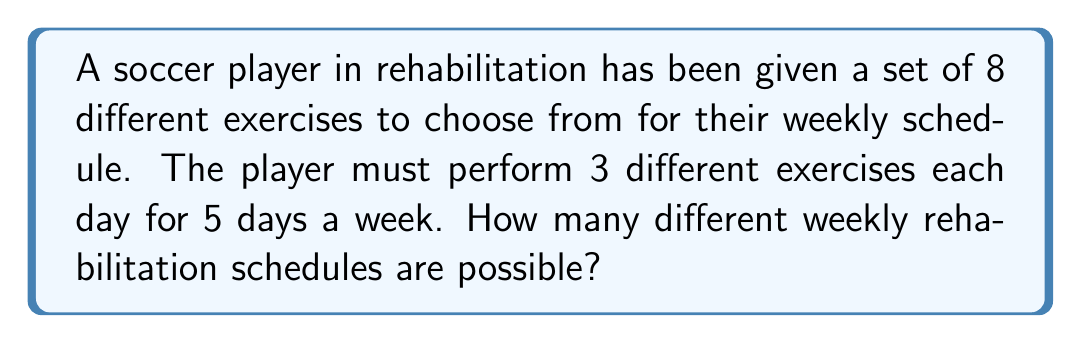Help me with this question. Let's approach this step-by-step:

1) First, we need to calculate how many ways we can choose 3 exercises out of 8 for a single day. This is a combination problem, denoted as $\binom{8}{3}$ or $C(8,3)$.

   $\binom{8}{3} = \frac{8!}{3!(8-3)!} = \frac{8!}{3!5!} = 56$

2) Now, for each day, we have 56 different combinations of exercises to choose from.

3) The schedule is for 5 days, and the order of the days matters (Monday's exercises can be different from Tuesday's, etc.). This means we're dealing with a multiplication principle scenario.

4) Therefore, we need to multiply the number of choices for each day:

   $56 \times 56 \times 56 \times 56 \times 56 = 56^5$

5) Calculate $56^5$:
   
   $56^5 = 3,076,243,456$

Thus, there are 3,076,243,456 different possible weekly rehabilitation schedules.
Answer: $56^5 = 3,076,243,456$ 